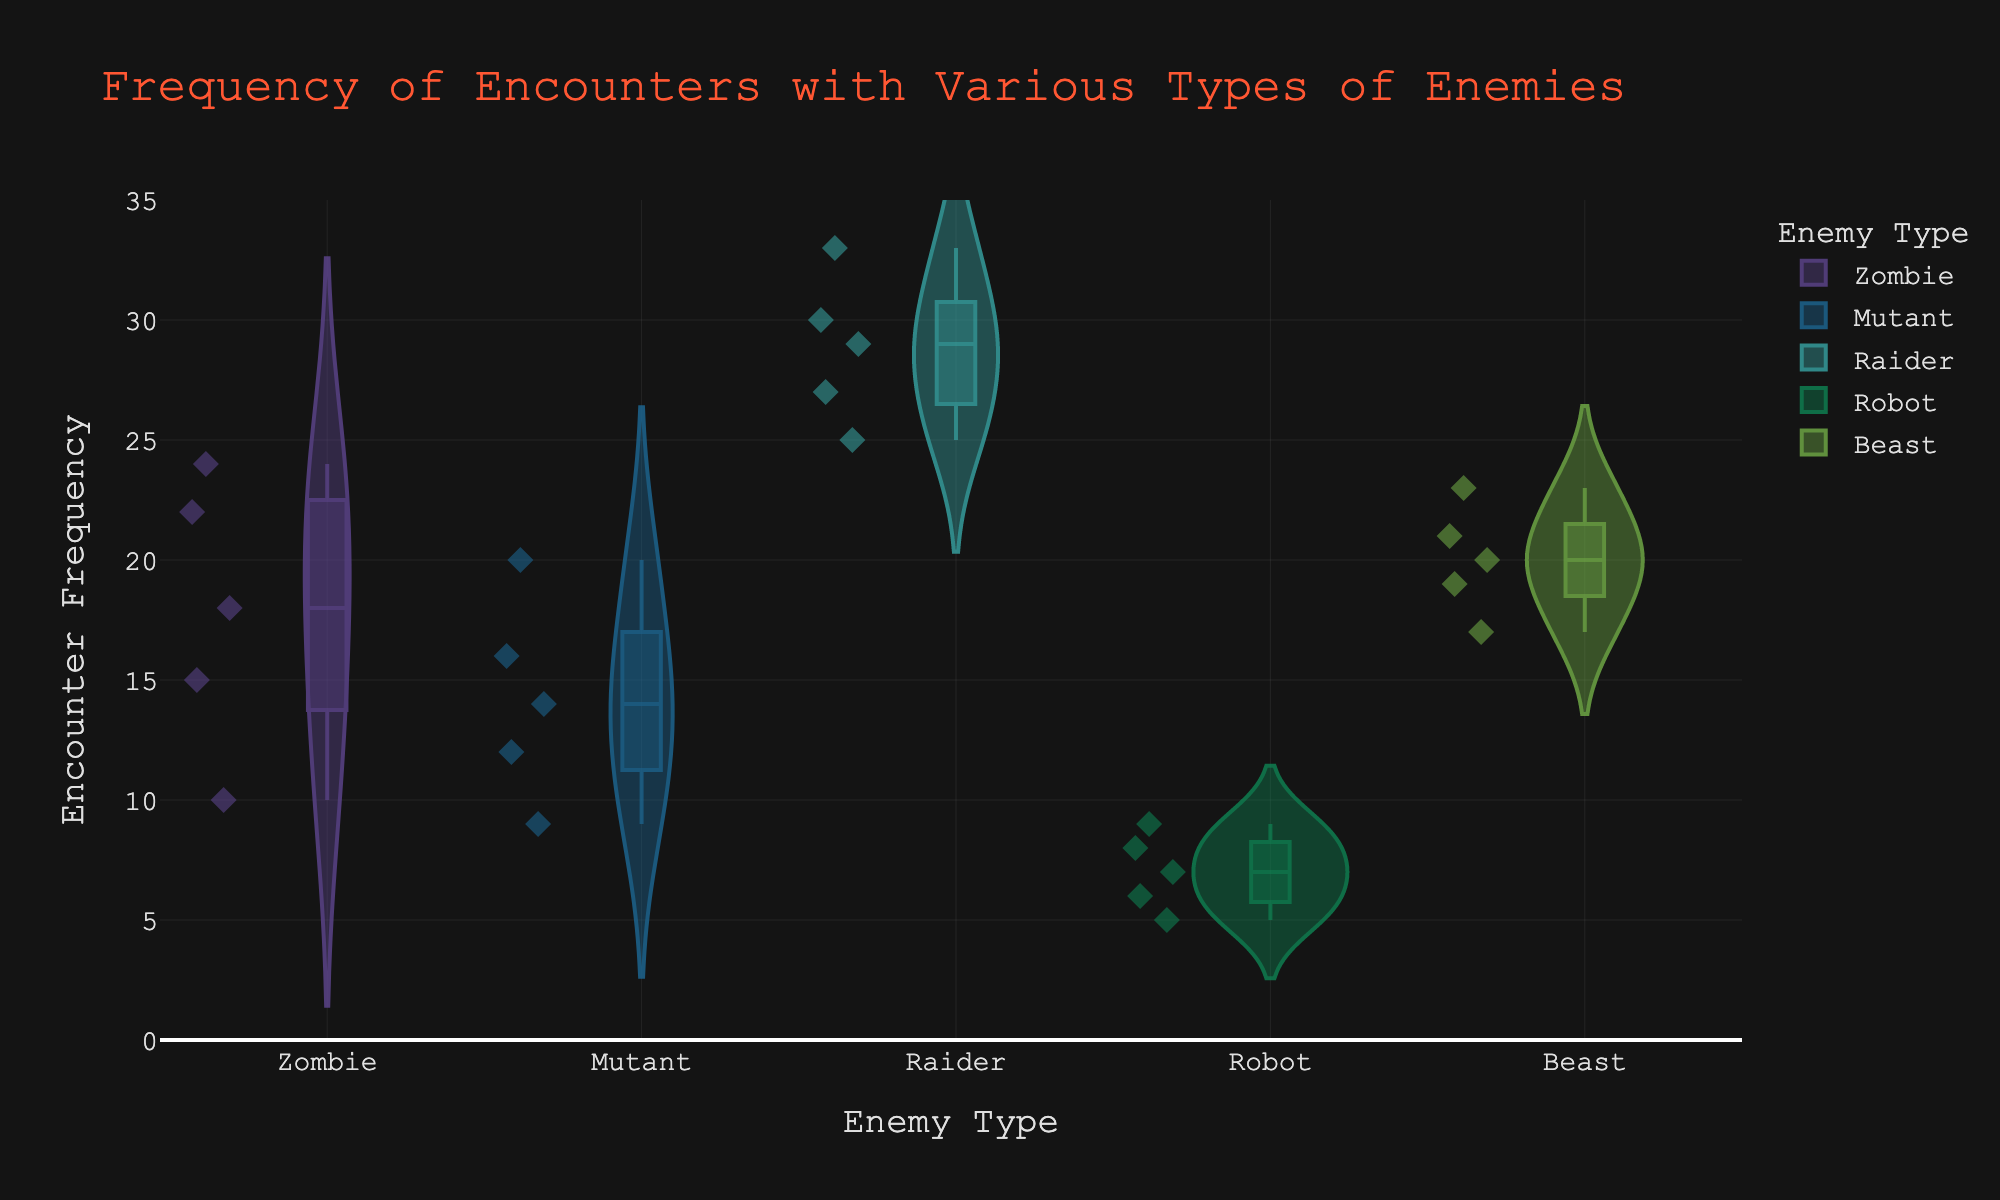what is the title of the plot? The title is displayed at the top of the figure in larger font size and a distinct color.
Answer: Frequency of Encounters with Various Types of Enemies which enemy type has the highest median frequency of encounters? The median value is shown as the middle line within the box plot on the violin plots. The Raider type has the highest median because its box is the highest along the y-axis.
Answer: Raider how many enemy types are represented in the plot? The x-axis lists different enemy types, which can be counted easily. There are five distinct enemy types: Zombie, Mutant, Raider, Robot, and Beast.
Answer: 5 what is the range of encounter frequencies for robots? The range refers to the difference between the maximum and minimum values in the violin plot for Robots. The maximum frequency for Robots is 9, and the minimum is 5. The range is 9 - 5 = 4.
Answer: 4 which enemy type has the widest distribution of encounter frequencies? Distribution width can be visualized by the spread or width of the violin plot. The Zombie type has the widest distribution since its plot is the widest horizontally.
Answer: Zombie compare the median encounter frequencies of Zombies and Mutants. Locate the median line in the box plots for both Zombies and Mutants. The median for Zombies is higher than that for Mutants.
Answer: Zombies have a higher median what is the average frequency of encounters with Beasts? Add the encounter frequencies for Beasts and divide by the number of data points. Sum = 19 + 23 + 21 + 17 + 20 = 100. Average = 100 / 5 = 20.
Answer: 20 are there any enemy types with a single mode of encounter frequency? Check if any violin plot has a clear peak indicating the most frequent encounter frequency. None of the enemy types exhibit a single mode; all have a spread of values.
Answer: No how does the range of encounter frequencies for Raiders compare to that of Robots? Calculate the range for both. Raiders: 33 - 25 = 8. Robots: 9 - 5 = 4. Raiders have a wider range than Robots.
Answer: Raiders have a wider range which enemy type has an outlier, and what is its value? Outliers are displayed as individual points outside the box plot. No outliers are visually represented for any enemy type in the plot.
Answer: None 